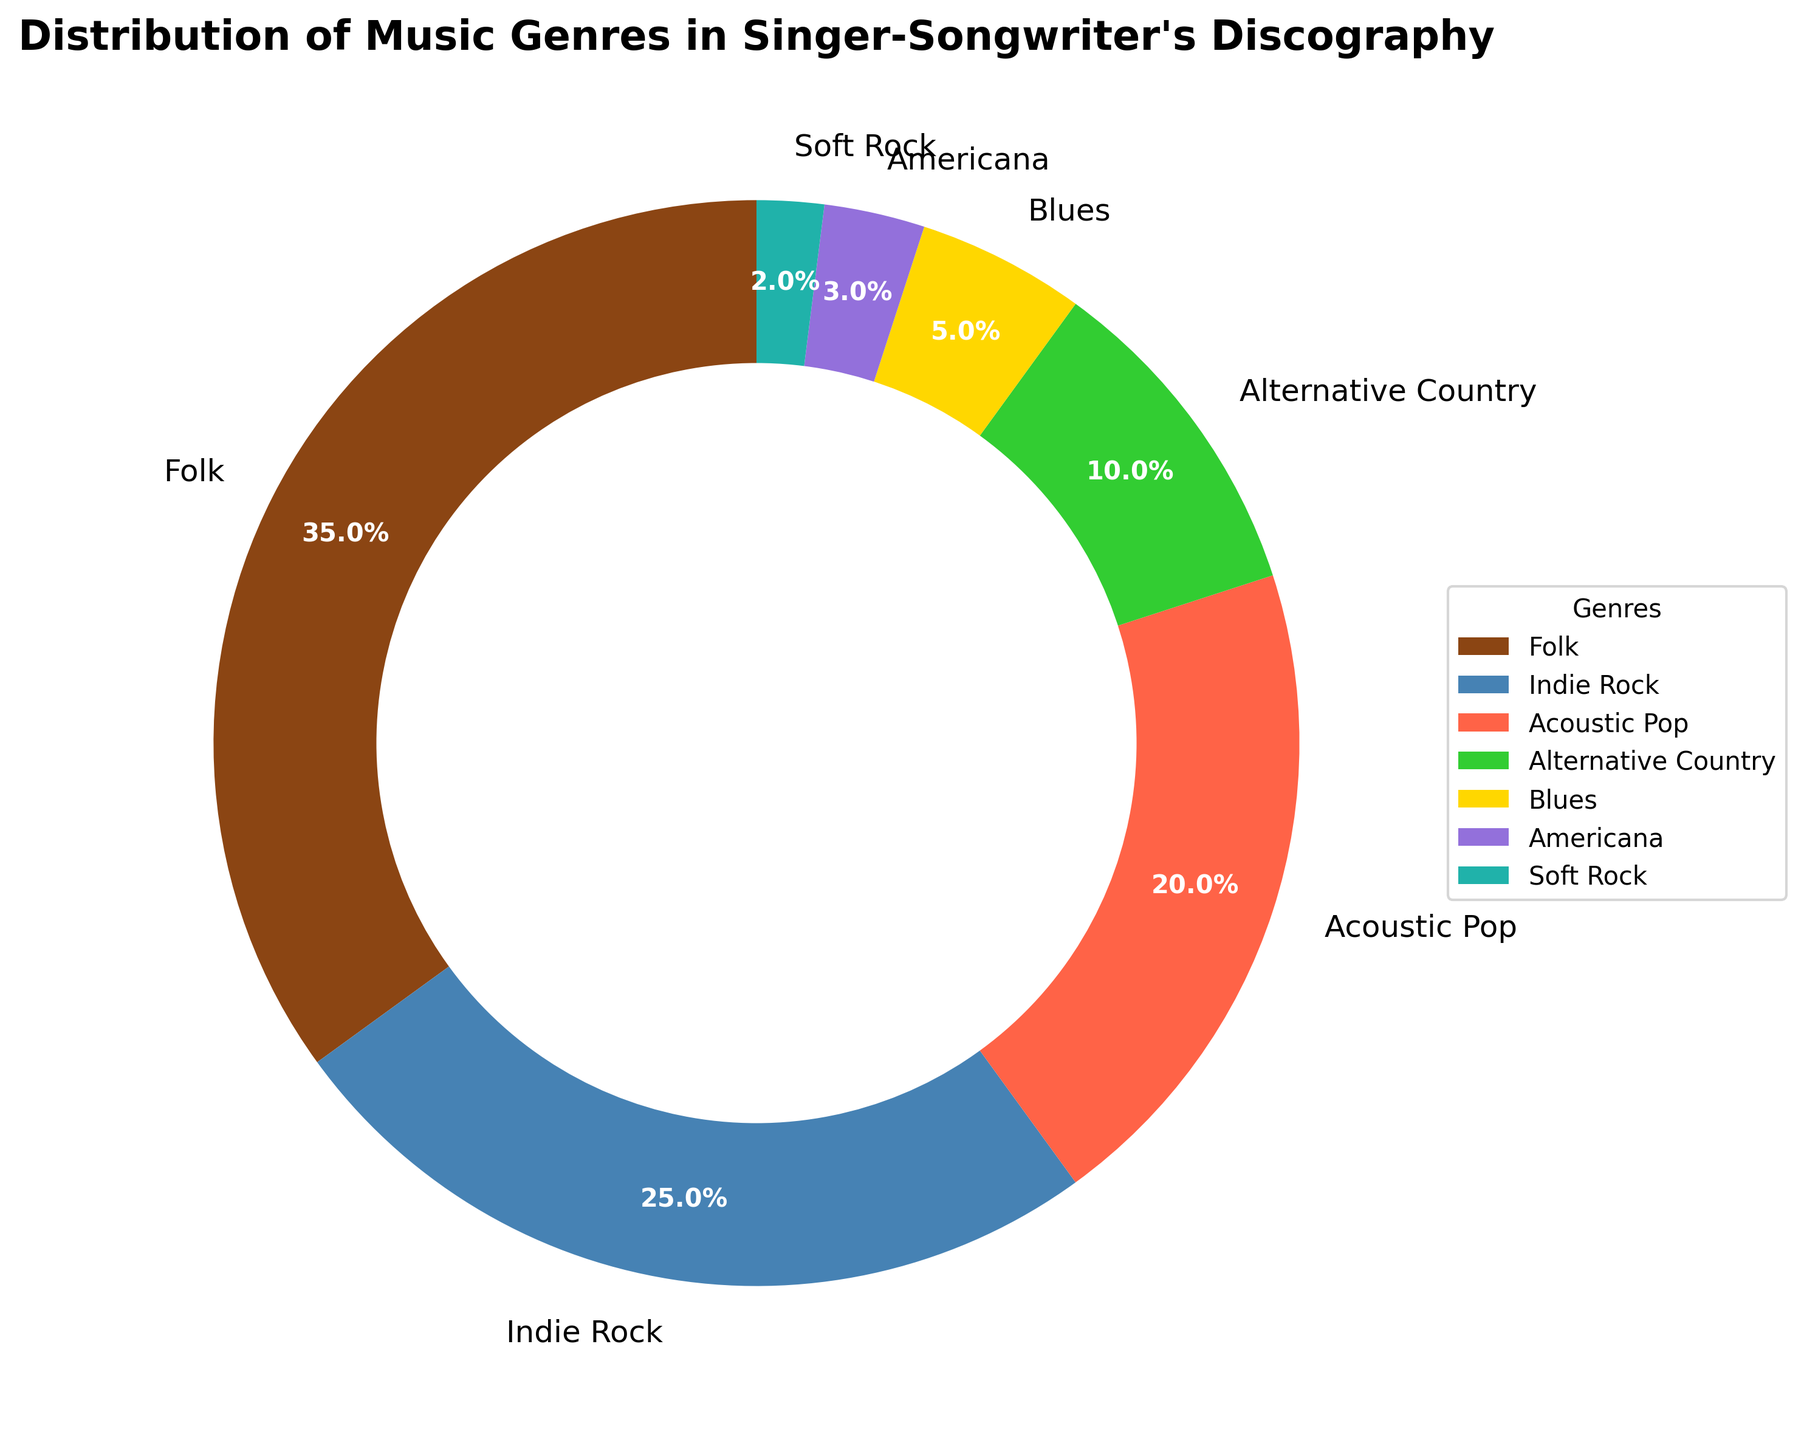what is the most represented genre in the singer-songwriter's discography? By looking at the pie chart, the largest segment corresponds to the Folk genre. The chart shows that Folk has the highest percentage.
Answer: Folk Which genre has a higher percentage, Indie Rock or Acoustic Pop? By comparing the sizes of the pie chart segments, Indie Rock and Acoustic Pop can be compared. Indie Rock has a larger segment and thus a higher percentage.
Answer: Indie Rock What is the combined percentage for the genres with the smallest shares in the discography? To find the combined percentage, sum the percentages of Blues (5%), Americana (3%), and Soft Rock (2%). 5 + 3 + 2 = 10
Answer: 10 How does the percentage of Alternative Country compare to that of Blues? Observing the pie chart, the Alternative Country segment is larger than the Blues segment, indicating a higher percentage for Alternative Country.
Answer: Alternative Country What are the two least represented genres, and what is their combined percentage? Identify the smallest segments in the pie chart. The two least represented genres are Americana (3%) and Soft Rock (2%). Combine their percentages: 3 + 2 = 5
Answer: Americana and Soft Rock, 5 Which genre has a smaller percentage, Soft Rock or Americana? By observing the segments in the pie chart, it is clear that the Soft Rock segment is smaller than the Americana segment.
Answer: Soft Rock What is the total percentage of the three most prominent genres? Sum the percentages of Folk (35%), Indie Rock (25%), and Acoustic Pop (20%). 35 + 25 + 20 = 80
Answer: 80 Is the percentage of Acoustic Pop greater than or equal to the combined percentages of Blues and Americana? Compare the percentage of Acoustic Pop (20%) to the sum of Blues (5%) and Americana (3%). 20% is greater than 8%.
Answer: Yes How does the percentage of Indie Rock compare to the sum of Alternative Country and Blues? Sum the percentages of Alternative Country (10%) and Blues (5%) to get 15%. Indie Rock has a percentage of 25%. 25 > 15
Answer: Indie Rock's percentage is higher 